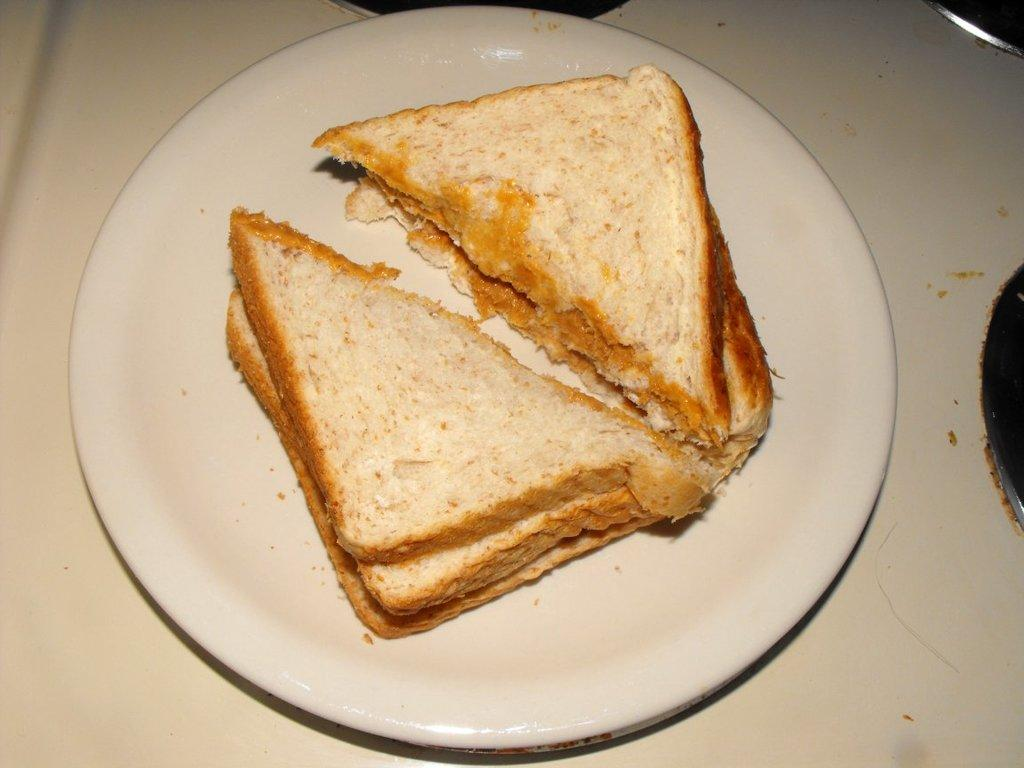What is on the plate that is visible in the image? There are food items on a plate in the image. What is the color of the surface on which the plate is placed? The plate is placed on a white-colored surface. Can you describe any other objects in the image besides the plate and food items? There are unspecified objects in the image. How many legs does the tramp have in the image? There is no tramp present in the image, so it is not possible to determine the number of legs it might have. 